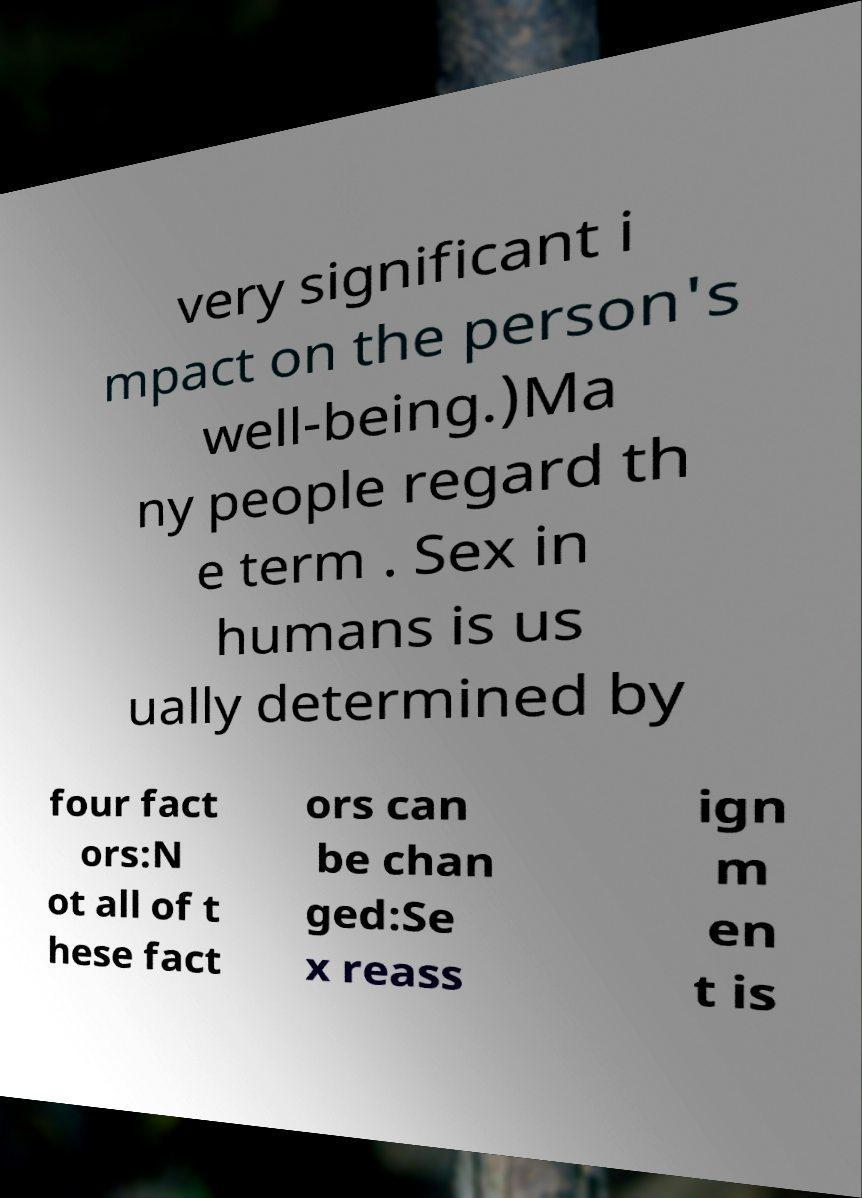Could you extract and type out the text from this image? very significant i mpact on the person's well-being.)Ma ny people regard th e term . Sex in humans is us ually determined by four fact ors:N ot all of t hese fact ors can be chan ged:Se x reass ign m en t is 